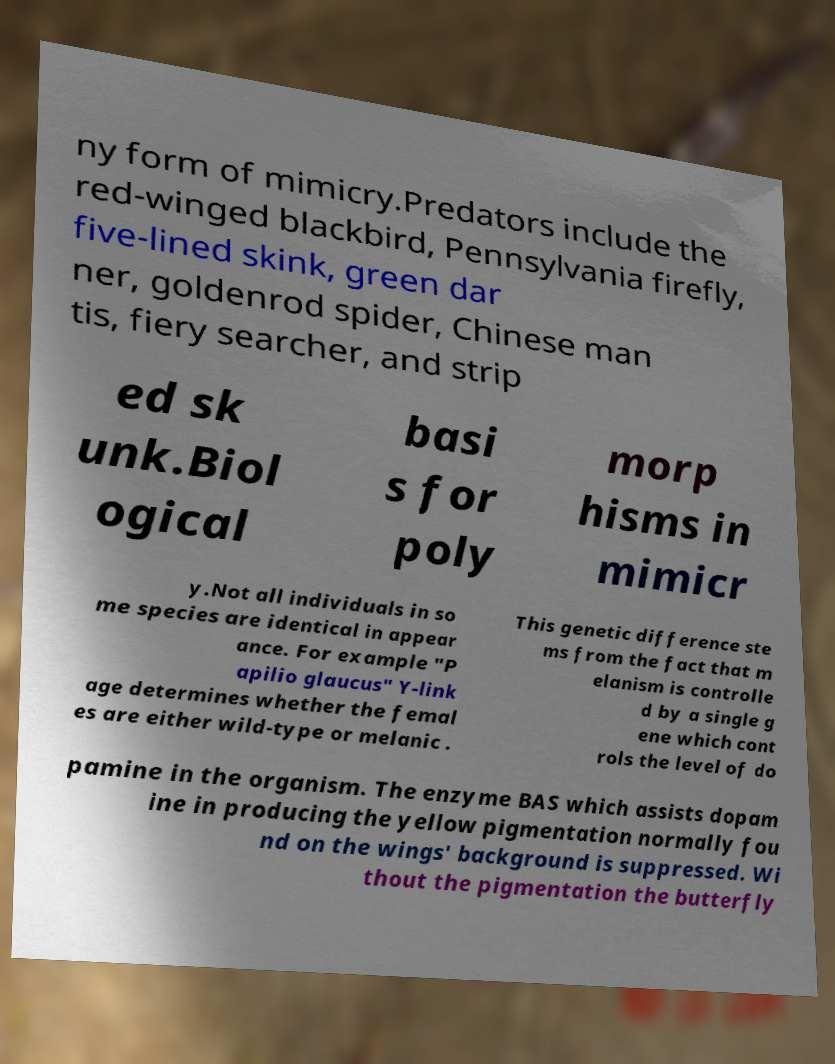For documentation purposes, I need the text within this image transcribed. Could you provide that? ny form of mimicry.Predators include the red-winged blackbird, Pennsylvania firefly, five-lined skink, green dar ner, goldenrod spider, Chinese man tis, fiery searcher, and strip ed sk unk.Biol ogical basi s for poly morp hisms in mimicr y.Not all individuals in so me species are identical in appear ance. For example "P apilio glaucus" Y-link age determines whether the femal es are either wild-type or melanic . This genetic difference ste ms from the fact that m elanism is controlle d by a single g ene which cont rols the level of do pamine in the organism. The enzyme BAS which assists dopam ine in producing the yellow pigmentation normally fou nd on the wings' background is suppressed. Wi thout the pigmentation the butterfly 